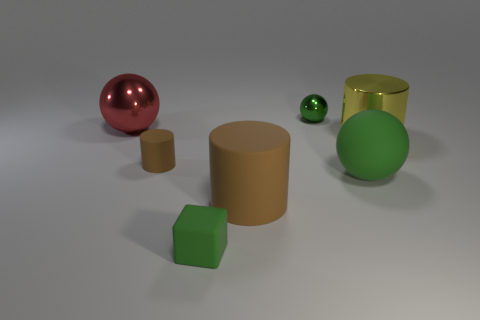Subtract all cyan spheres. How many brown cylinders are left? 2 Subtract 1 balls. How many balls are left? 2 Add 2 small brown matte cylinders. How many objects exist? 9 Subtract all blocks. How many objects are left? 6 Subtract 0 green cylinders. How many objects are left? 7 Subtract all small blue rubber objects. Subtract all tiny brown matte things. How many objects are left? 6 Add 6 tiny brown matte cylinders. How many tiny brown matte cylinders are left? 7 Add 4 tiny cyan matte spheres. How many tiny cyan matte spheres exist? 4 